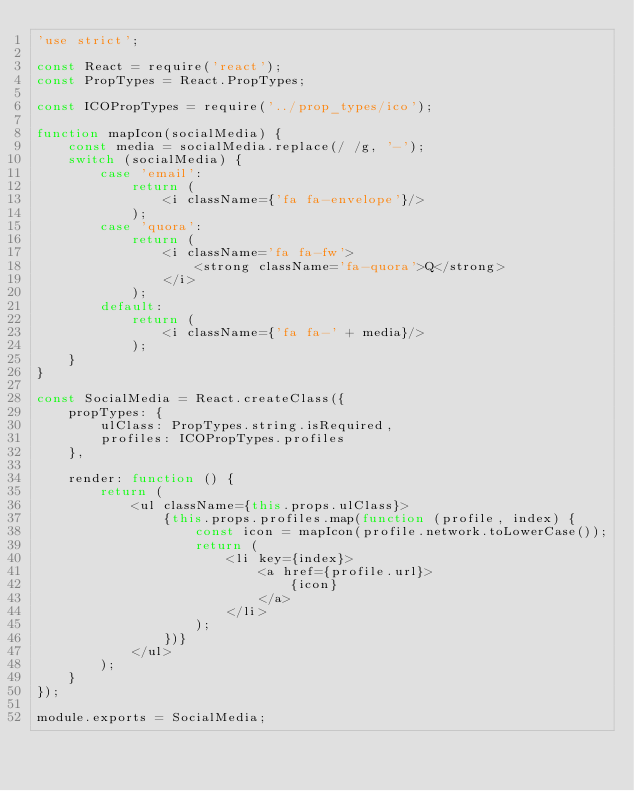<code> <loc_0><loc_0><loc_500><loc_500><_JavaScript_>'use strict';

const React = require('react');
const PropTypes = React.PropTypes;

const ICOPropTypes = require('../prop_types/ico');

function mapIcon(socialMedia) {
    const media = socialMedia.replace(/ /g, '-');
    switch (socialMedia) {
        case 'email':
            return (
                <i className={'fa fa-envelope'}/>
            );
        case 'quora':
            return (
                <i className='fa fa-fw'>
                    <strong className='fa-quora'>Q</strong>
                </i>
            );
        default:
            return (
                <i className={'fa fa-' + media}/>
            );
    }
}

const SocialMedia = React.createClass({
    propTypes: {
        ulClass: PropTypes.string.isRequired,
        profiles: ICOPropTypes.profiles
    },

    render: function () {
        return (
            <ul className={this.props.ulClass}>
                {this.props.profiles.map(function (profile, index) {
                    const icon = mapIcon(profile.network.toLowerCase());
                    return (
                        <li key={index}>
                            <a href={profile.url}>
                                {icon}
                            </a>
                        </li>
                    );
                })}
            </ul>
        );
    }
});

module.exports = SocialMedia;
</code> 